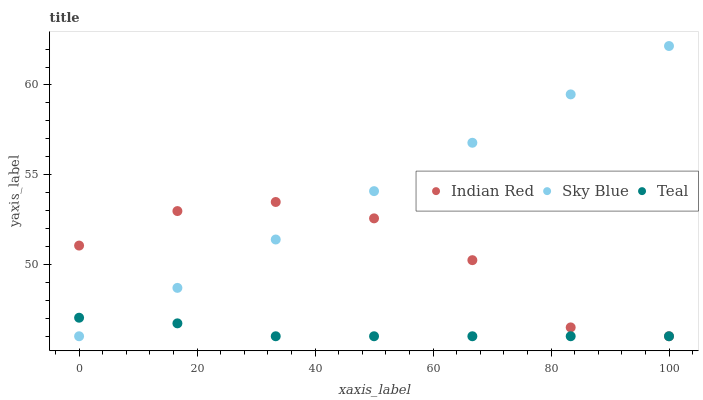Does Teal have the minimum area under the curve?
Answer yes or no. Yes. Does Sky Blue have the maximum area under the curve?
Answer yes or no. Yes. Does Indian Red have the minimum area under the curve?
Answer yes or no. No. Does Indian Red have the maximum area under the curve?
Answer yes or no. No. Is Sky Blue the smoothest?
Answer yes or no. Yes. Is Indian Red the roughest?
Answer yes or no. Yes. Is Teal the smoothest?
Answer yes or no. No. Is Teal the roughest?
Answer yes or no. No. Does Sky Blue have the lowest value?
Answer yes or no. Yes. Does Sky Blue have the highest value?
Answer yes or no. Yes. Does Indian Red have the highest value?
Answer yes or no. No. Does Sky Blue intersect Indian Red?
Answer yes or no. Yes. Is Sky Blue less than Indian Red?
Answer yes or no. No. Is Sky Blue greater than Indian Red?
Answer yes or no. No. 